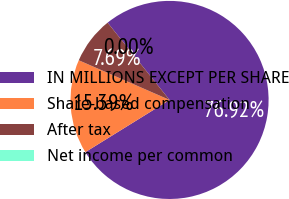Convert chart. <chart><loc_0><loc_0><loc_500><loc_500><pie_chart><fcel>IN MILLIONS EXCEPT PER SHARE<fcel>Share-based compensation<fcel>After tax<fcel>Net income per common<nl><fcel>76.92%<fcel>15.39%<fcel>7.69%<fcel>0.0%<nl></chart> 